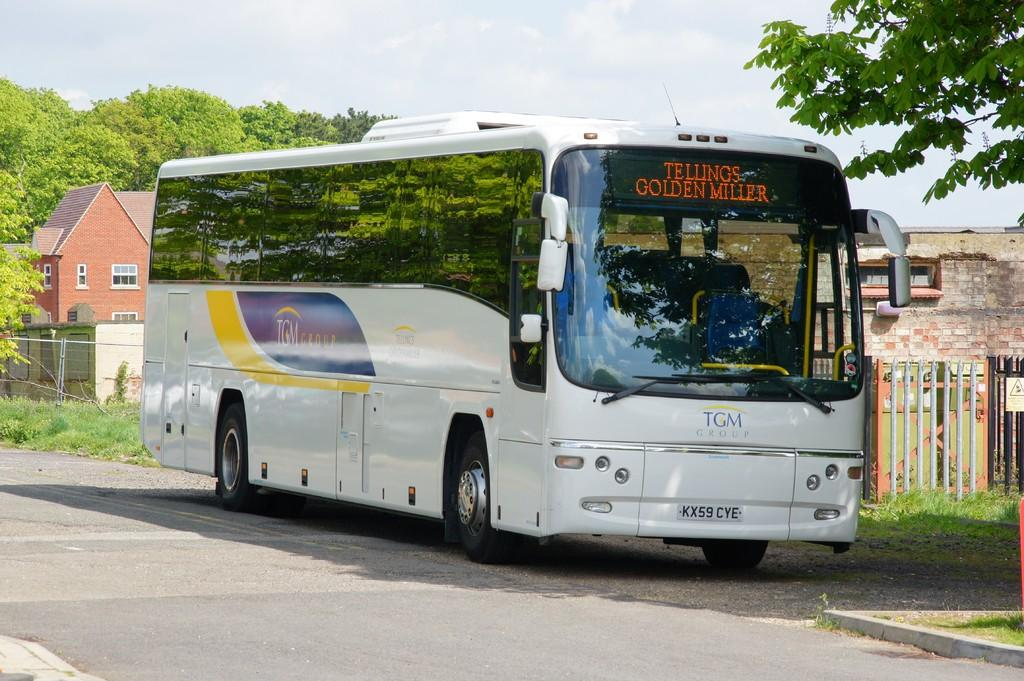What type of vehicle is in the image? There is a white bus in the image. Where is the bus located? The bus is on a road. What other structures can be seen in the image? There are fences, houses, and trees in the image. What is visible at the top of the image? The sky is visible at the top of the image. What caption is written on the side of the bus in the image? There is no caption visible on the side of the bus in the image. What type of business is being conducted in the image? The image does not depict any business activities; it shows a white bus on a road with other structures in the background. 